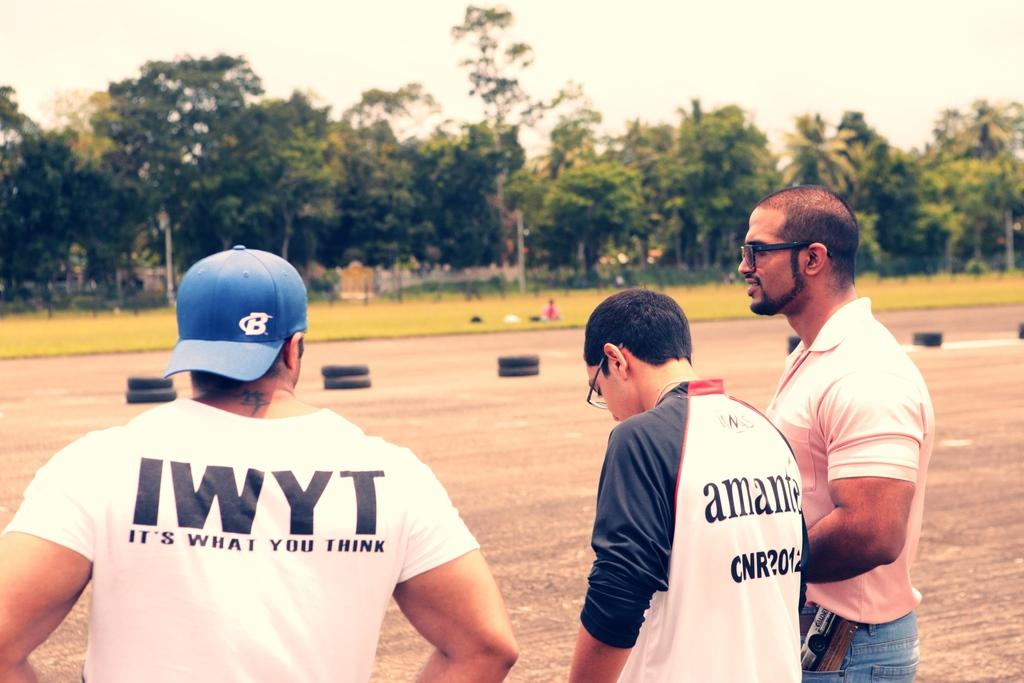<image>
Summarize the visual content of the image. A man wearing a blue hat and an IWYT shirt stands with his back towards the camera 